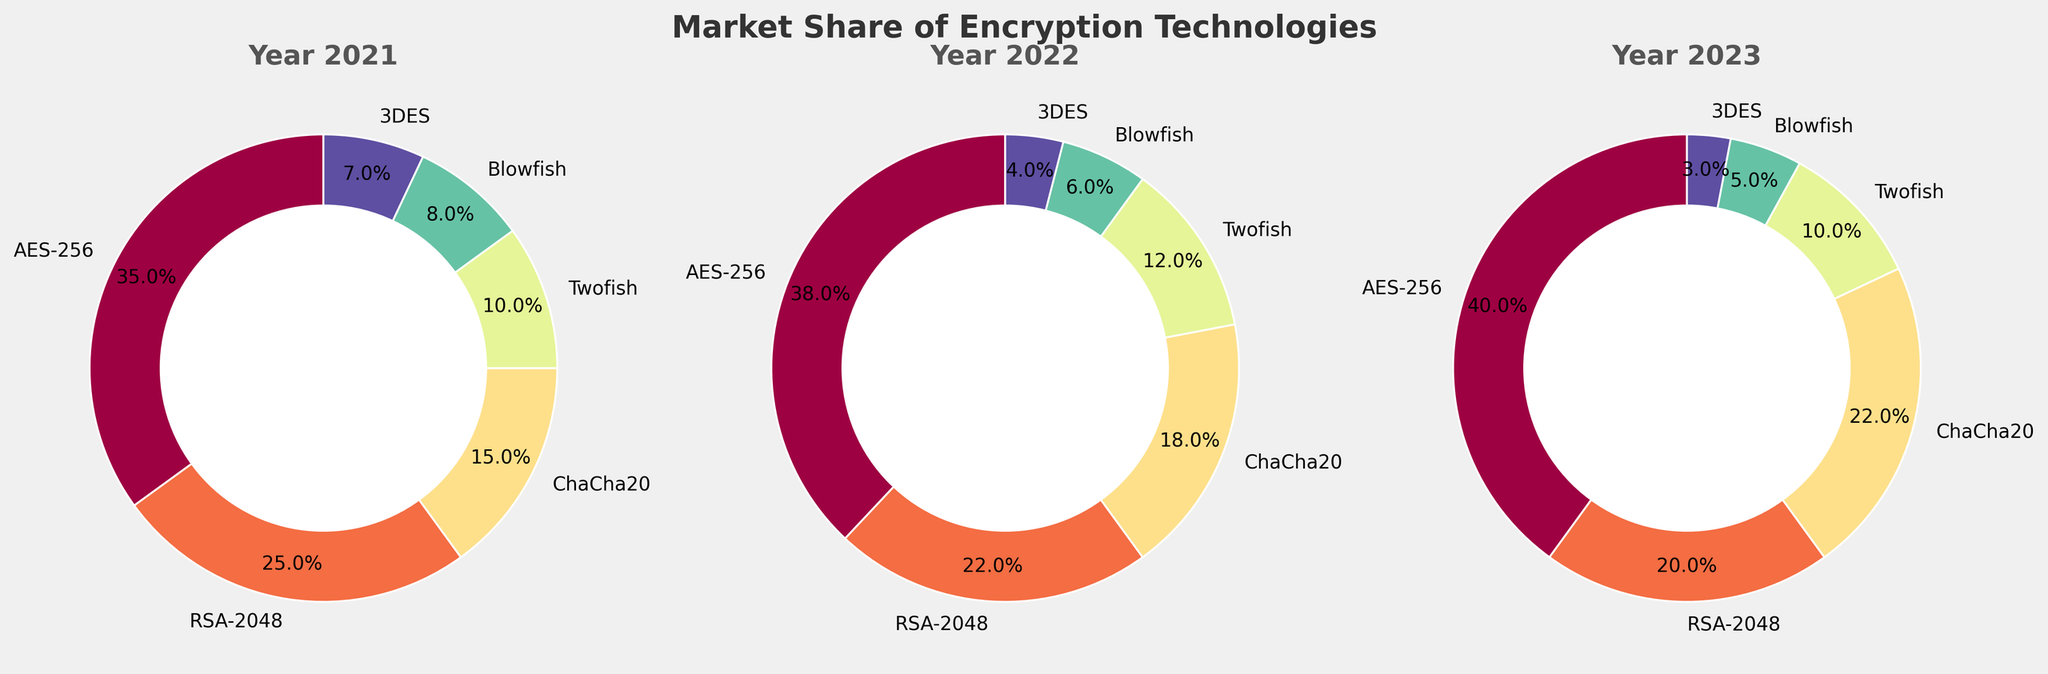Which encryption technology had the largest market share in 2021? By looking at the pie chart for the year 2021, identify the encryption technology with the largest slice. The largest slice corresponds to AES-256.
Answer: AES-256 Which encryption technology had the smallest market share in 2023? By looking at the pie chart for the year 2023, identify the encryption technology with the smallest slice. The smallest slice corresponds to 3DES.
Answer: 3DES How did the market share of AES-256 change from 2021 to 2023? Calculate the difference between the market shares of AES-256 in 2021 and 2023. The market share increased from 35% to 40%. Therefore, the change is 40% - 35% = 5%.
Answer: Increased by 5% Which encryption technology had the largest increase in market share between 2021 and 2023? Compare the market shares of each encryption technology in 2021 and 2023. ChaCha20 increased from 15% to 22%, which is the largest increase, a 7% increase.
Answer: ChaCha20 Between 2022 and 2023, which encryption technology saw a decrease in market share? Compare the market shares of each encryption technology in 2022 and 2023. Both RSA-2048 and 3DES saw decreases in market share. RSA-2048 decreased from 22% to 20% and 3DES decreased from 4% to 3%.
Answer: RSA-2048 and 3DES What is the average market share of Twofish over the years 2021, 2022, and 2023? The market shares of Twofish are 10% in 2021, 12% in 2022, and 10% in 2023. Calculate the average: (10 + 12 + 10) / 3 = 32 / 3 ≈ 10.67%.
Answer: 10.67% Comparing 2021 and 2023, did the total market share of AES-256 and ChaCha20 combined increase or decrease? In 2021, AES-256 had 35% and ChaCha20 had 15%, totaling 50%. In 2023, AES-256 had 40% and ChaCha20 had 22%, totaling 62%. The combined market share increased.
Answer: Increased In which year did Blowfish have the least market share? By looking at the pie charts for all three years, identify the smallest slice for Blowfish. The smallest slice for Blowfish is in 2023 with 5%.
Answer: 2023 What is the total market share of RSA-2048 and 3DES in 2022? In 2022, RSA-2048 had 22% and 3DES had 4%. Add these two values to get the total market share: 22% + 4% = 26%.
Answer: 26% By what percentage did Blowfish's market share change from 2021 to 2022? Subtract Blowfish's market share in 2021 from its market share in 2022. The market share changed from 8% to 6%, so the difference is 8 - 6 = 2%.
Answer: Decreased by 2% 